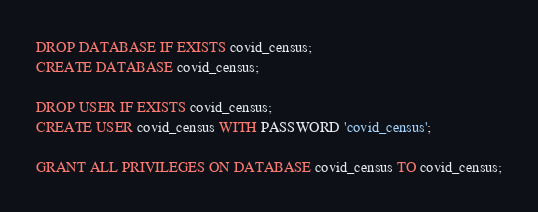Convert code to text. <code><loc_0><loc_0><loc_500><loc_500><_SQL_>DROP DATABASE IF EXISTS covid_census;
CREATE DATABASE covid_census;

DROP USER IF EXISTS covid_census;
CREATE USER covid_census WITH PASSWORD 'covid_census';

GRANT ALL PRIVILEGES ON DATABASE covid_census TO covid_census;</code> 